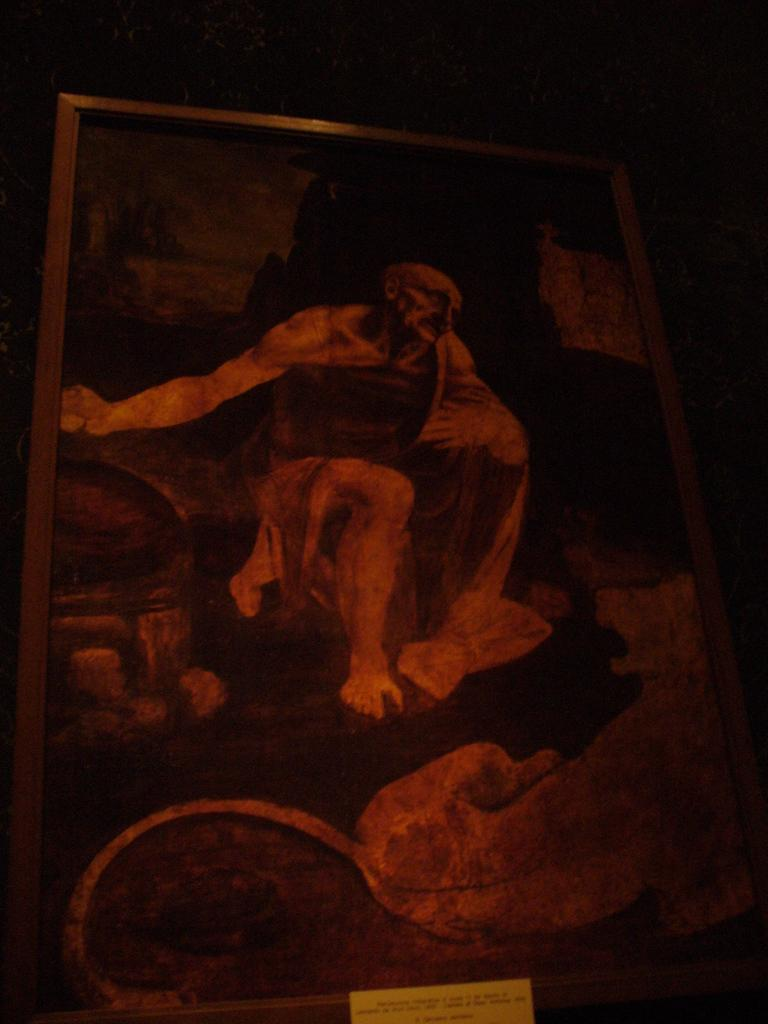What is the main subject of the painting in the image? There is a painting of a person in the image. Can you describe the background of the painting? The background of the painting is dark. What type of locket is the person wearing in the painting? There is no locket visible in the painting; the person is not wearing any jewelry. Can you tell me how many boats are in the background of the painting? There are no boats present in the painting; the background is dark. 